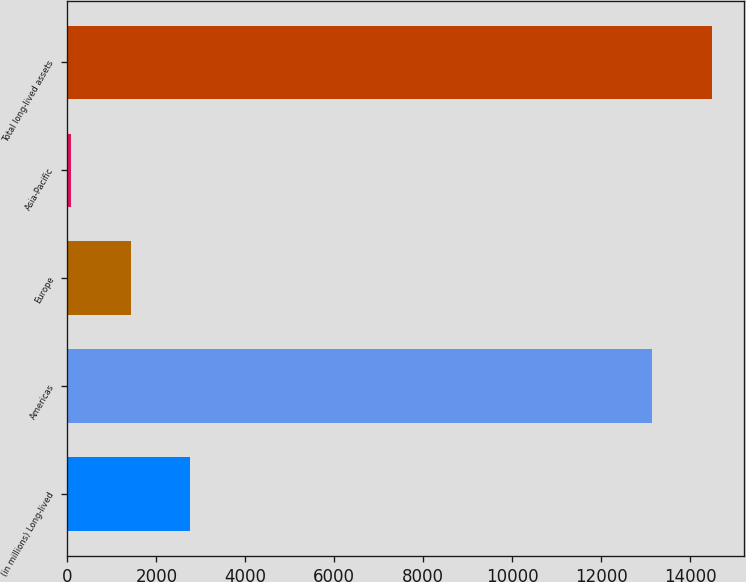Convert chart to OTSL. <chart><loc_0><loc_0><loc_500><loc_500><bar_chart><fcel>(in millions) Long-lived<fcel>Americas<fcel>Europe<fcel>Asia-Pacific<fcel>Total long-lived assets<nl><fcel>2752<fcel>13151<fcel>1417.5<fcel>83<fcel>14485.5<nl></chart> 